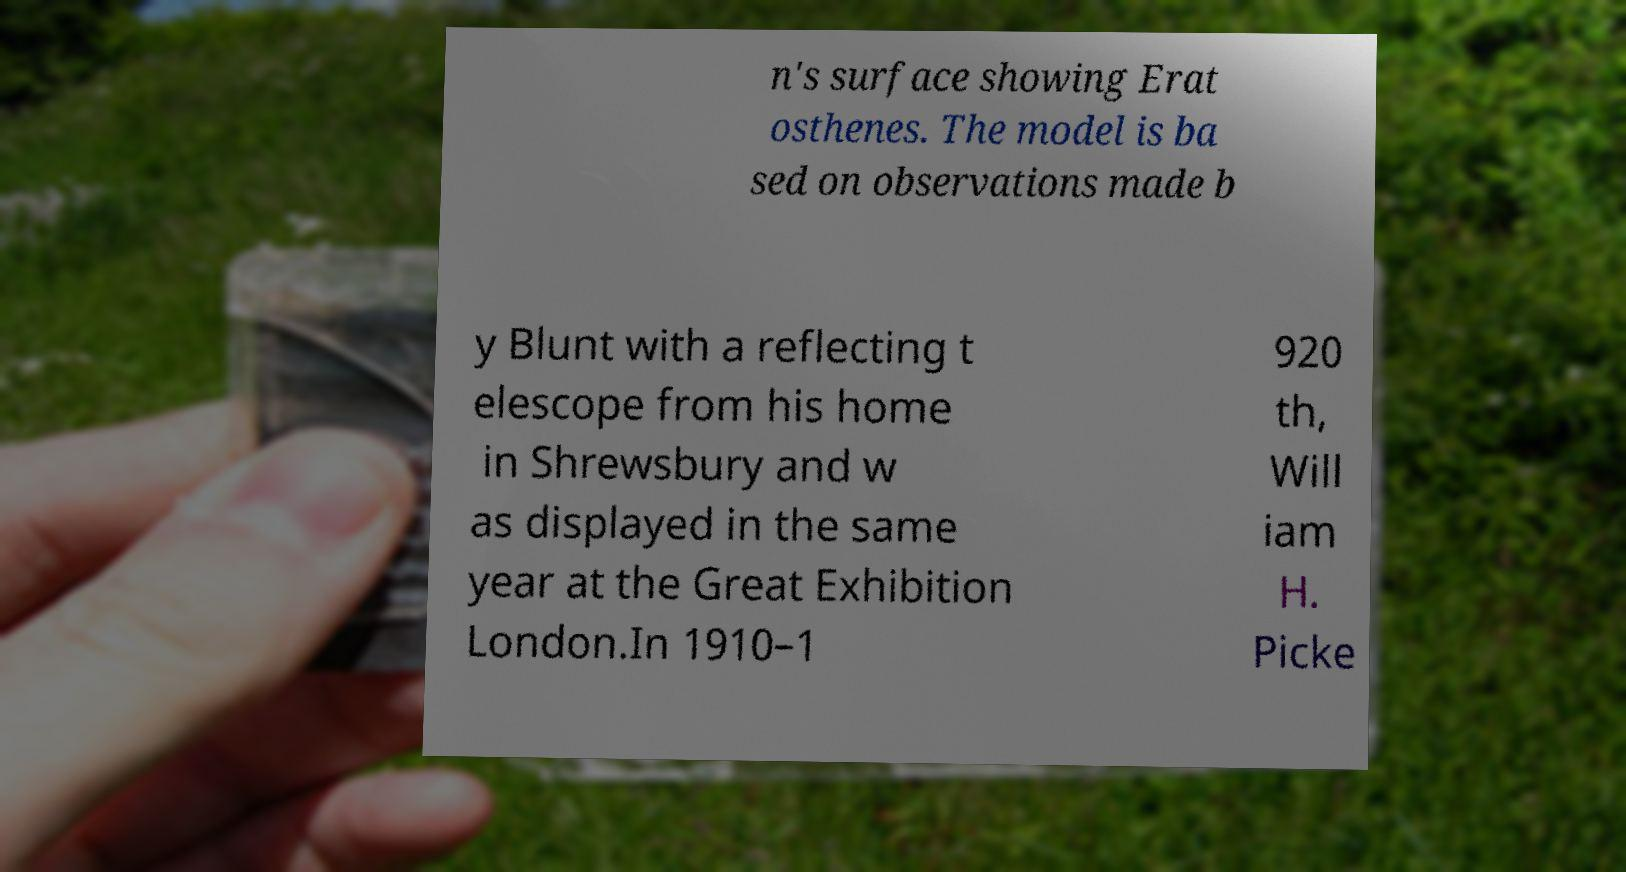Could you extract and type out the text from this image? n's surface showing Erat osthenes. The model is ba sed on observations made b y Blunt with a reflecting t elescope from his home in Shrewsbury and w as displayed in the same year at the Great Exhibition London.In 1910–1 920 th, Will iam H. Picke 